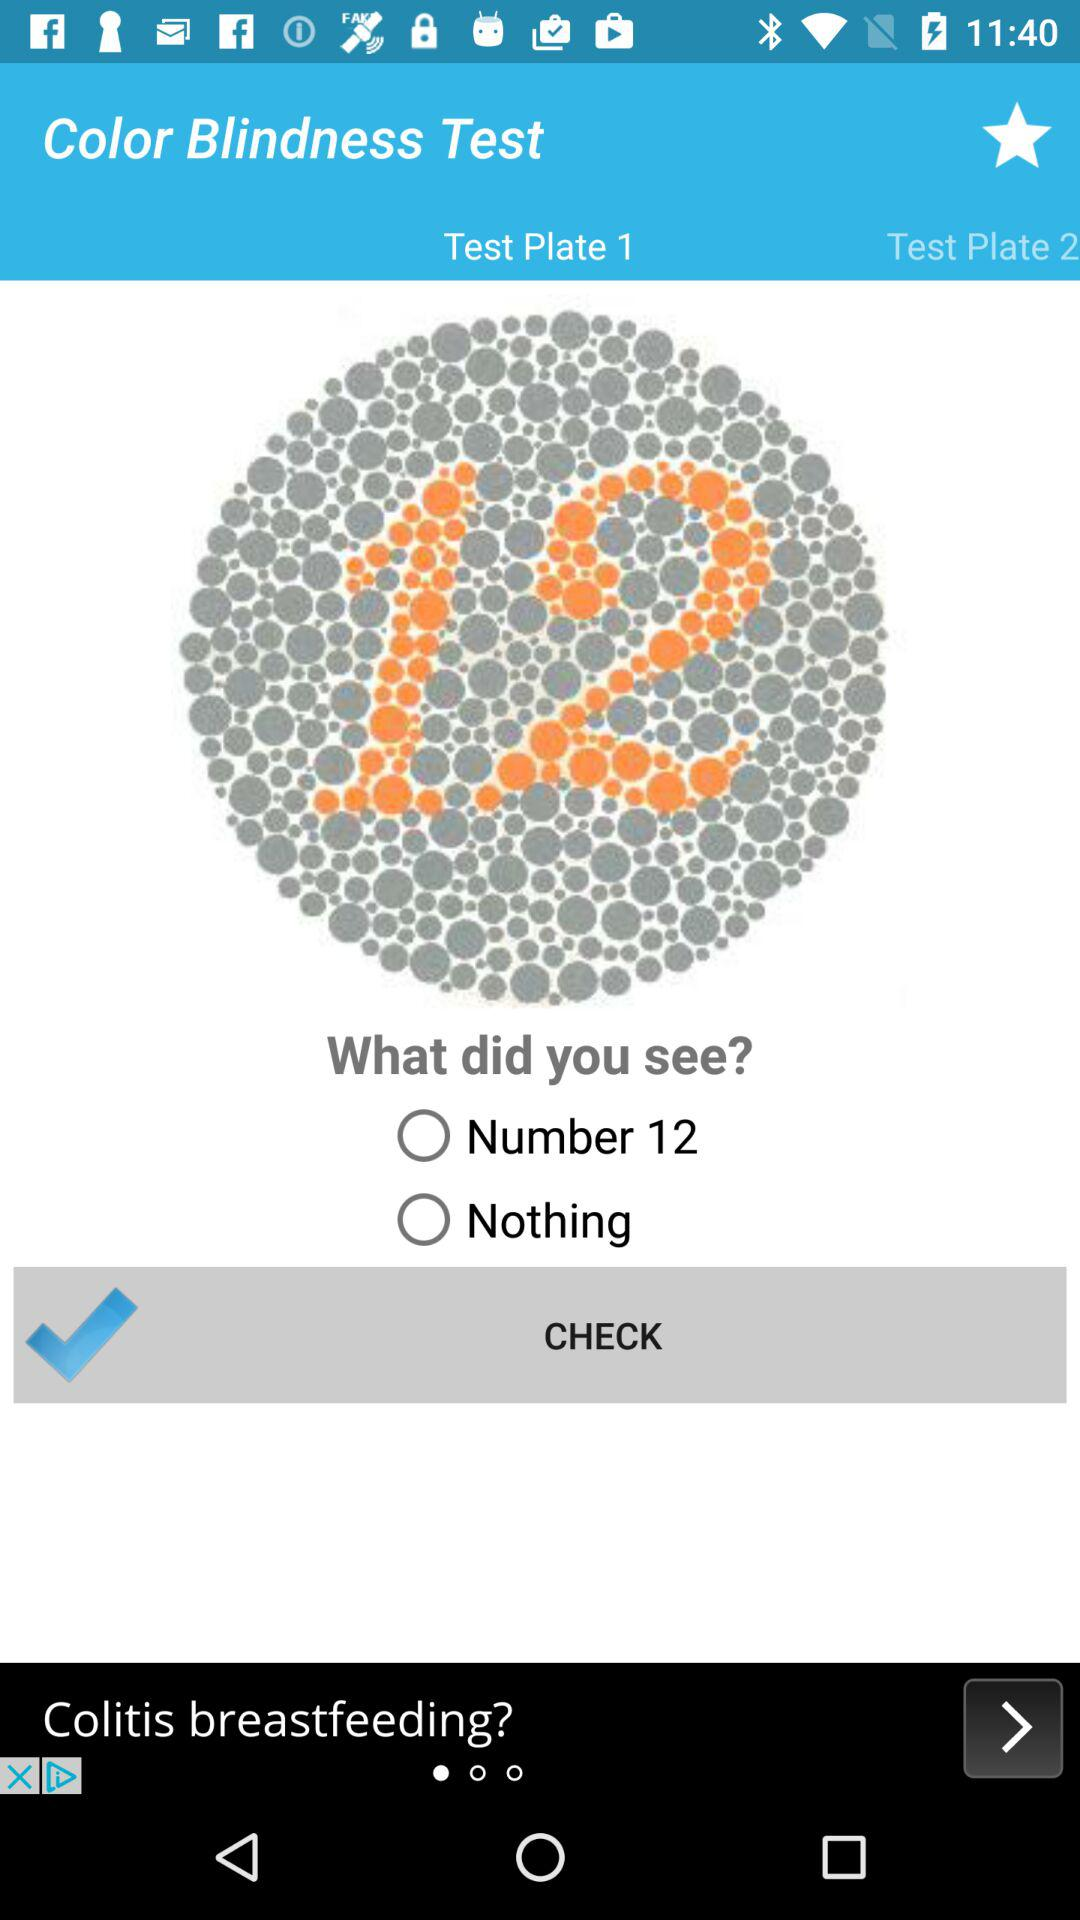What is the name of the test?
When the provided information is insufficient, respond with <no answer>. <no answer> 